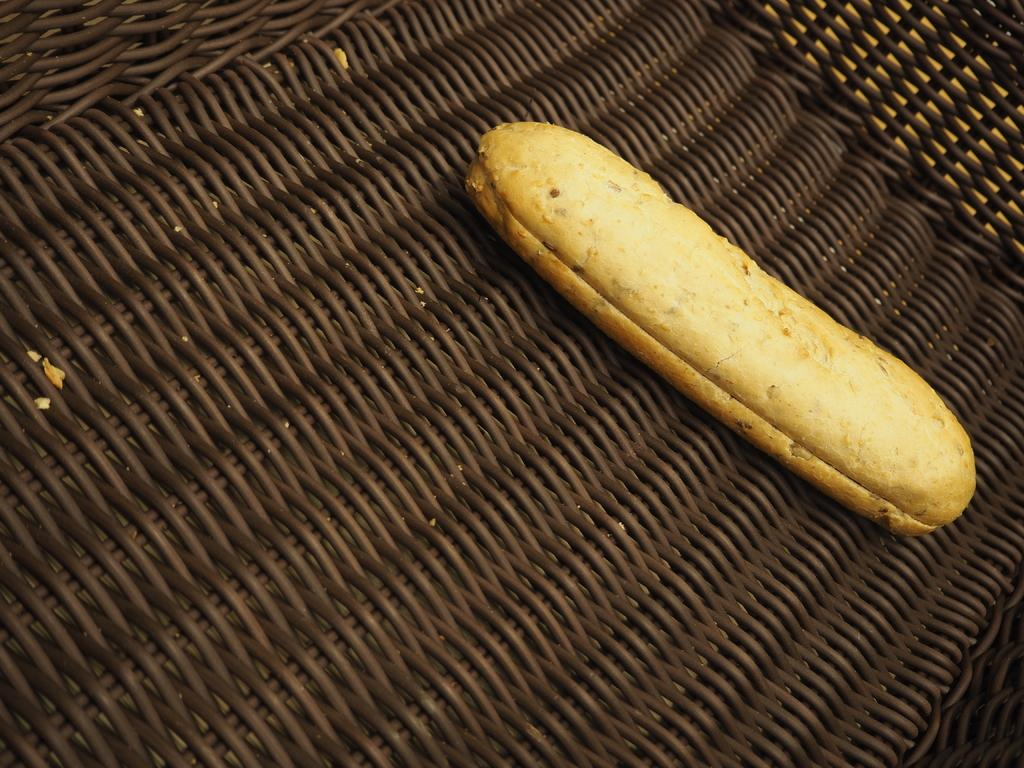What type of furniture is present in the image? There is a table in the image. What is placed on the table? There is a food item on the table. What level of expertise does the fireman have in the image? There is no fireman present in the image. What type of beam is supporting the table in the image? The image does not provide information about any beams supporting the table. 